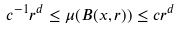Convert formula to latex. <formula><loc_0><loc_0><loc_500><loc_500>c ^ { - 1 } r ^ { d } \leq \mu ( B ( x , r ) ) \leq c r ^ { d }</formula> 